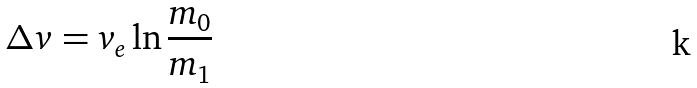Convert formula to latex. <formula><loc_0><loc_0><loc_500><loc_500>\Delta v = v _ { e } \ln \frac { m _ { 0 } } { m _ { 1 } }</formula> 